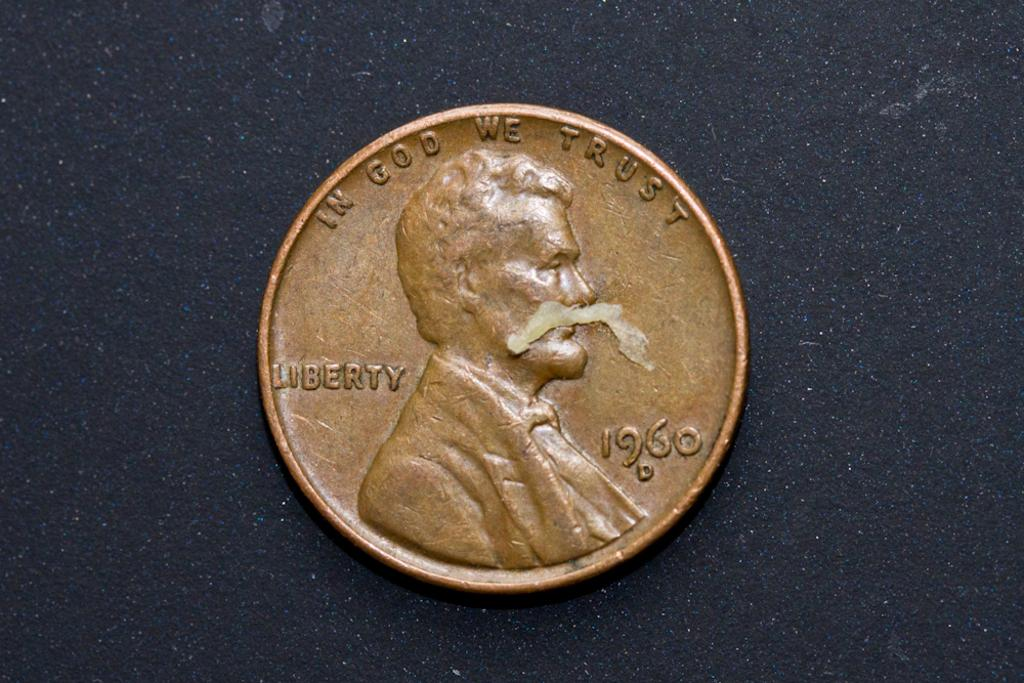<image>
Write a terse but informative summary of the picture. A LIBERTY coin from 1960 with text: "In God We Trust" 